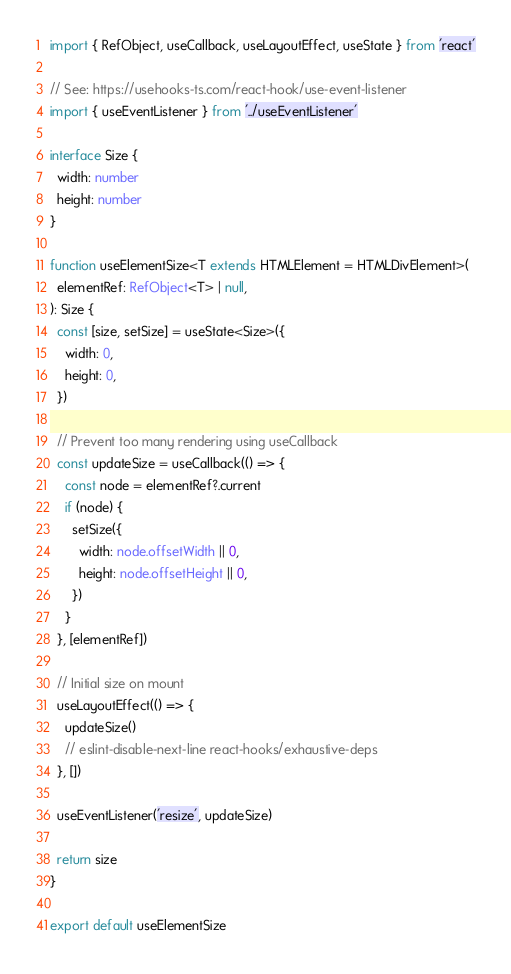Convert code to text. <code><loc_0><loc_0><loc_500><loc_500><_TypeScript_>import { RefObject, useCallback, useLayoutEffect, useState } from 'react'

// See: https://usehooks-ts.com/react-hook/use-event-listener
import { useEventListener } from '../useEventListener'

interface Size {
  width: number
  height: number
}

function useElementSize<T extends HTMLElement = HTMLDivElement>(
  elementRef: RefObject<T> | null,
): Size {
  const [size, setSize] = useState<Size>({
    width: 0,
    height: 0,
  })

  // Prevent too many rendering using useCallback
  const updateSize = useCallback(() => {
    const node = elementRef?.current
    if (node) {
      setSize({
        width: node.offsetWidth || 0,
        height: node.offsetHeight || 0,
      })
    }
  }, [elementRef])

  // Initial size on mount
  useLayoutEffect(() => {
    updateSize()
    // eslint-disable-next-line react-hooks/exhaustive-deps
  }, [])

  useEventListener('resize', updateSize)

  return size
}

export default useElementSize
</code> 